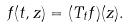<formula> <loc_0><loc_0><loc_500><loc_500>f ( t , z ) = ( T _ { t } f ) ( z ) .</formula> 